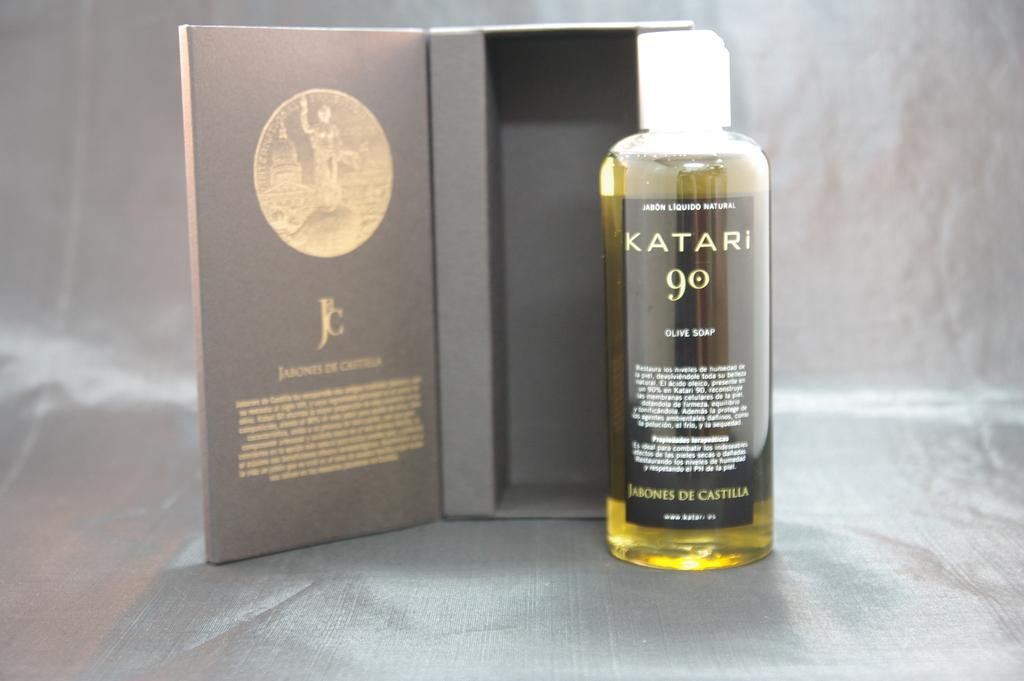What is the main object in the image with text on it? There is a box with text in the image. What is the other object in the image that contains a substance? There is a bottle with liquid inside the image. Where are the box and the bottle located in the image? Both the box and the bottle are placed on a surface. How many beds can be seen in the image? There are no beds present in the image. What is the cause of the liquid in the bottle in the image? The cause of the liquid in the bottle cannot be determined from the image alone. 